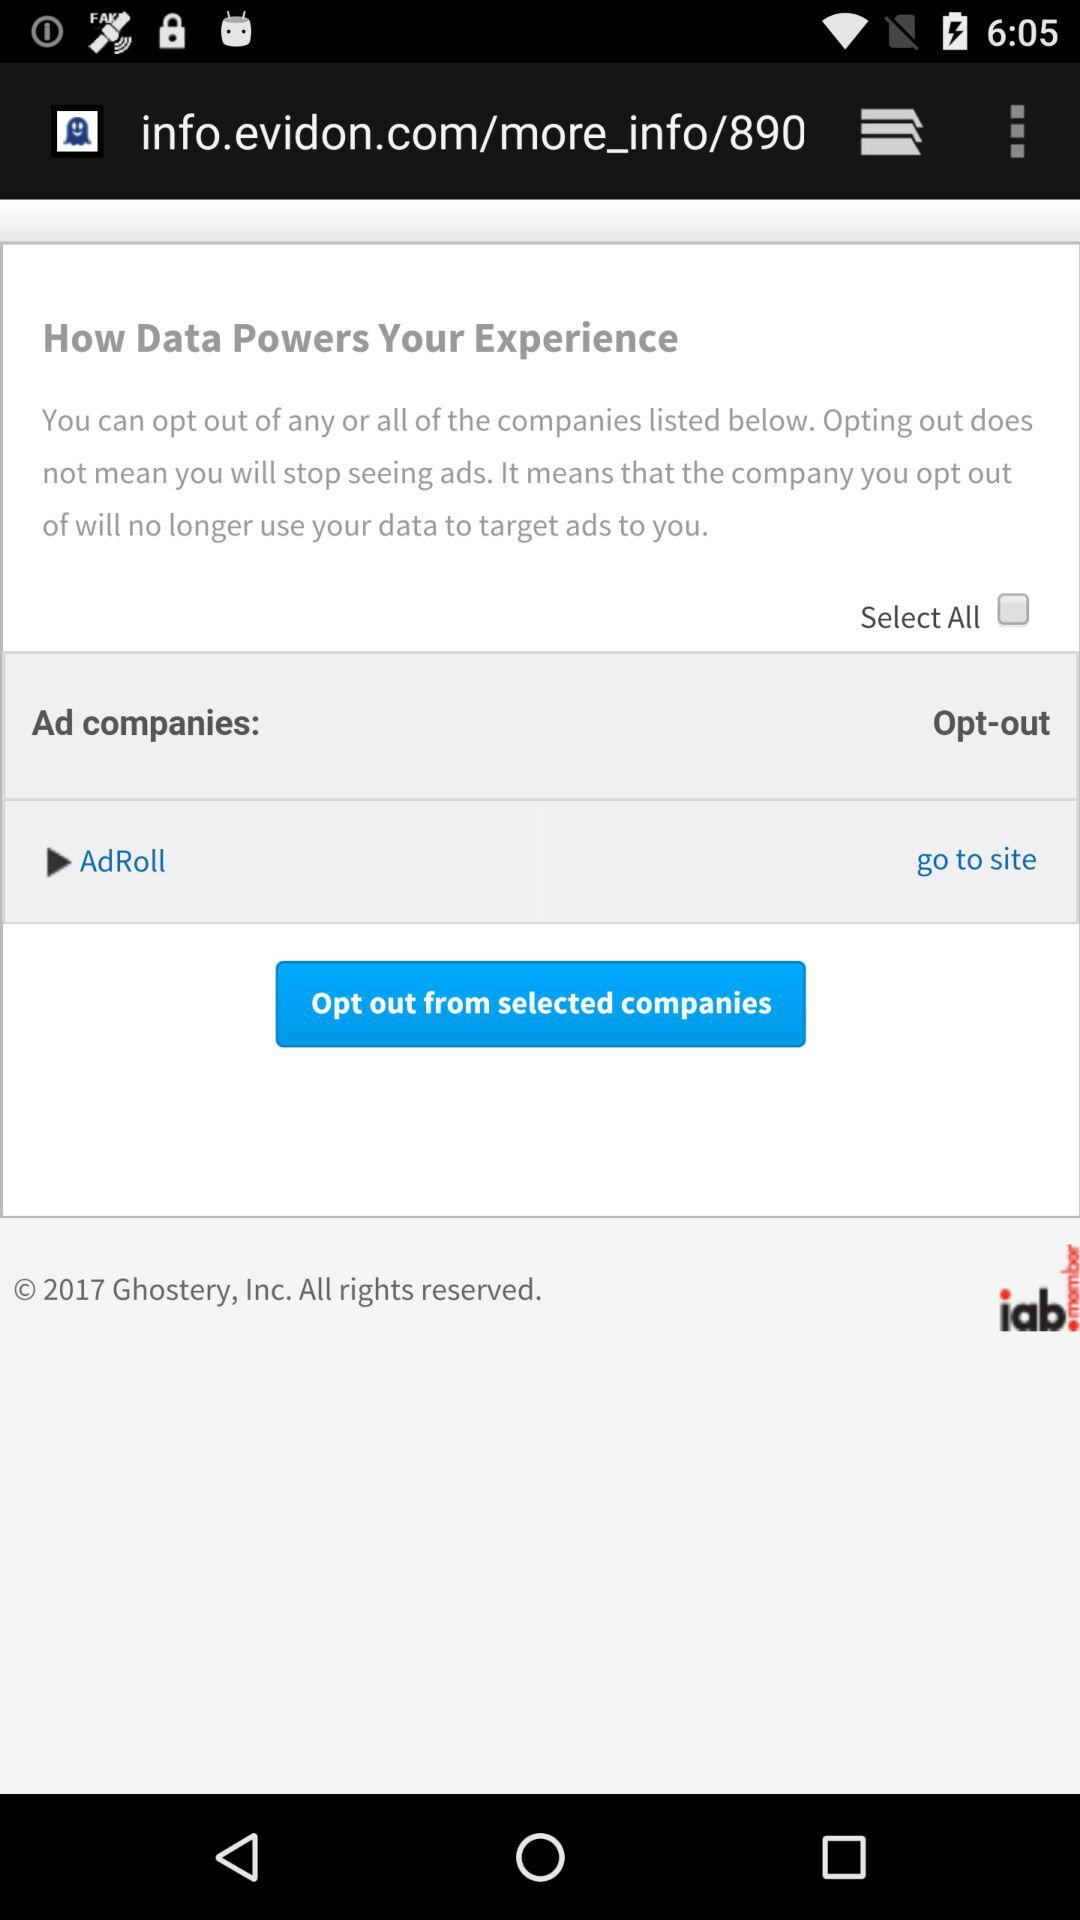How can I stop seeing ads?
When the provided information is insufficient, respond with <no answer>. <no answer> 